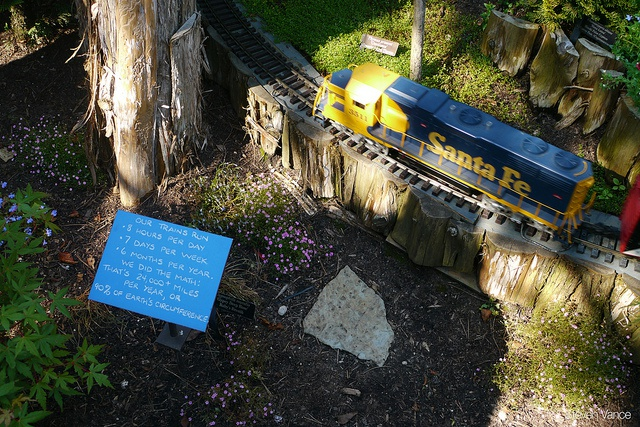Describe the objects in this image and their specific colors. I can see a train in black, blue, and navy tones in this image. 